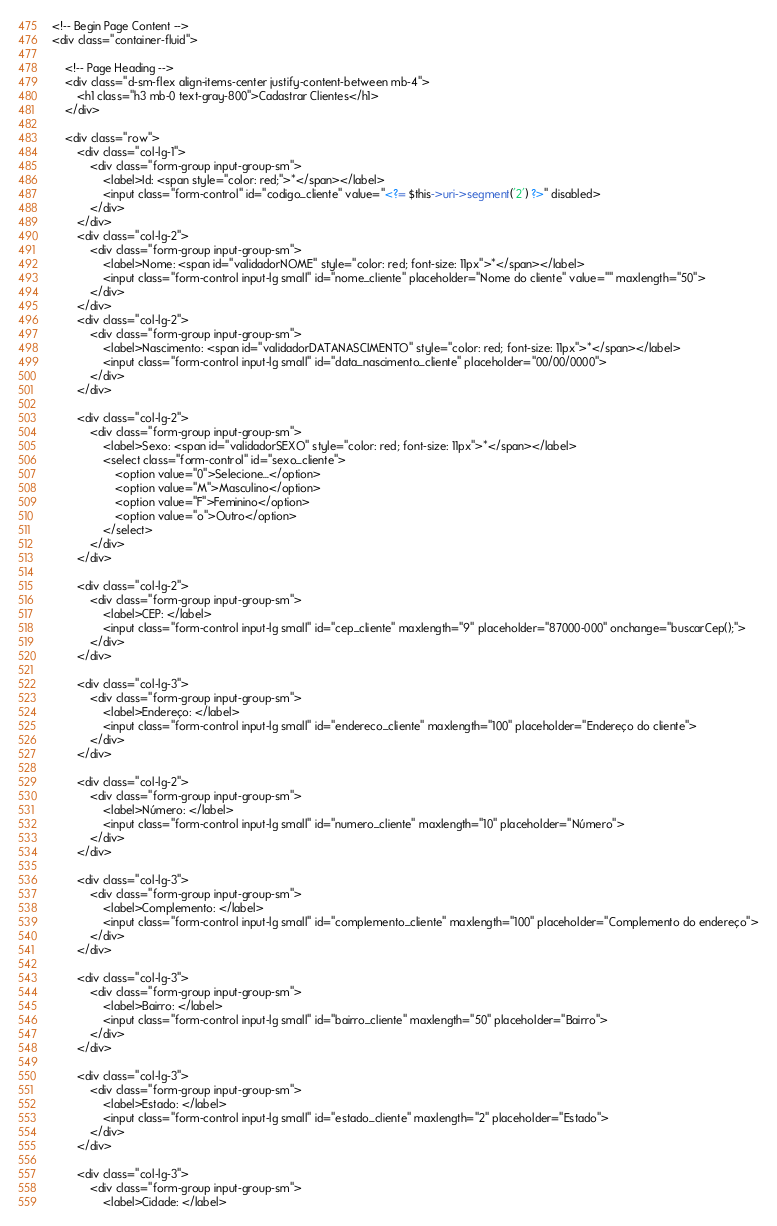Convert code to text. <code><loc_0><loc_0><loc_500><loc_500><_PHP_><!-- Begin Page Content -->
<div class="container-fluid">

    <!-- Page Heading -->
    <div class="d-sm-flex align-items-center justify-content-between mb-4">
        <h1 class="h3 mb-0 text-gray-800">Cadastrar Clientes</h1>
    </div>

    <div class="row">
        <div class="col-lg-1">
            <div class="form-group input-group-sm">
                <label>Id: <span style="color: red;">*</span></label>
                <input class="form-control" id="codigo_cliente" value="<?= $this->uri->segment('2') ?>" disabled>
            </div>
        </div>
        <div class="col-lg-2">
            <div class="form-group input-group-sm">
                <label>Nome: <span id="validadorNOME" style="color: red; font-size: 11px">*</span></label>
                <input class="form-control input-lg small" id="nome_cliente" placeholder="Nome do cliente" value="" maxlength="50">
            </div>
        </div>
        <div class="col-lg-2">
            <div class="form-group input-group-sm">
                <label>Nascimento: <span id="validadorDATANASCIMENTO" style="color: red; font-size: 11px">*</span></label>
                <input class="form-control input-lg small" id="data_nascimento_cliente" placeholder="00/00/0000">
            </div>
        </div>

        <div class="col-lg-2">
            <div class="form-group input-group-sm">
                <label>Sexo: <span id="validadorSEXO" style="color: red; font-size: 11px">*</span></label>
                <select class="form-control" id="sexo_cliente">
                    <option value="0">Selecione...</option>
                    <option value="M">Masculino</option>
                    <option value="F">Feminino</option>
                    <option value="o">Outro</option>
                </select>
            </div>
        </div>

        <div class="col-lg-2">
            <div class="form-group input-group-sm">
                <label>CEP: </label>
                <input class="form-control input-lg small" id="cep_cliente" maxlength="9" placeholder="87000-000" onchange="buscarCep();">
            </div>
        </div>

        <div class="col-lg-3">
            <div class="form-group input-group-sm">
                <label>Endereço: </label>
                <input class="form-control input-lg small" id="endereco_cliente" maxlength="100" placeholder="Endereço do cliente">
            </div>
        </div>

        <div class="col-lg-2">
            <div class="form-group input-group-sm">
                <label>Número: </label>
                <input class="form-control input-lg small" id="numero_cliente" maxlength="10" placeholder="Número">
            </div>
        </div>

        <div class="col-lg-3">
            <div class="form-group input-group-sm">
                <label>Complemento: </label>
                <input class="form-control input-lg small" id="complemento_cliente" maxlength="100" placeholder="Complemento do endereço">
            </div>
        </div>

        <div class="col-lg-3">
            <div class="form-group input-group-sm">
                <label>Bairro: </label>
                <input class="form-control input-lg small" id="bairro_cliente" maxlength="50" placeholder="Bairro">
            </div>
        </div>

        <div class="col-lg-3">
            <div class="form-group input-group-sm">
                <label>Estado: </label>
                <input class="form-control input-lg small" id="estado_cliente" maxlength="2" placeholder="Estado">
            </div>
        </div>

        <div class="col-lg-3">
            <div class="form-group input-group-sm">
                <label>Cidade: </label></code> 